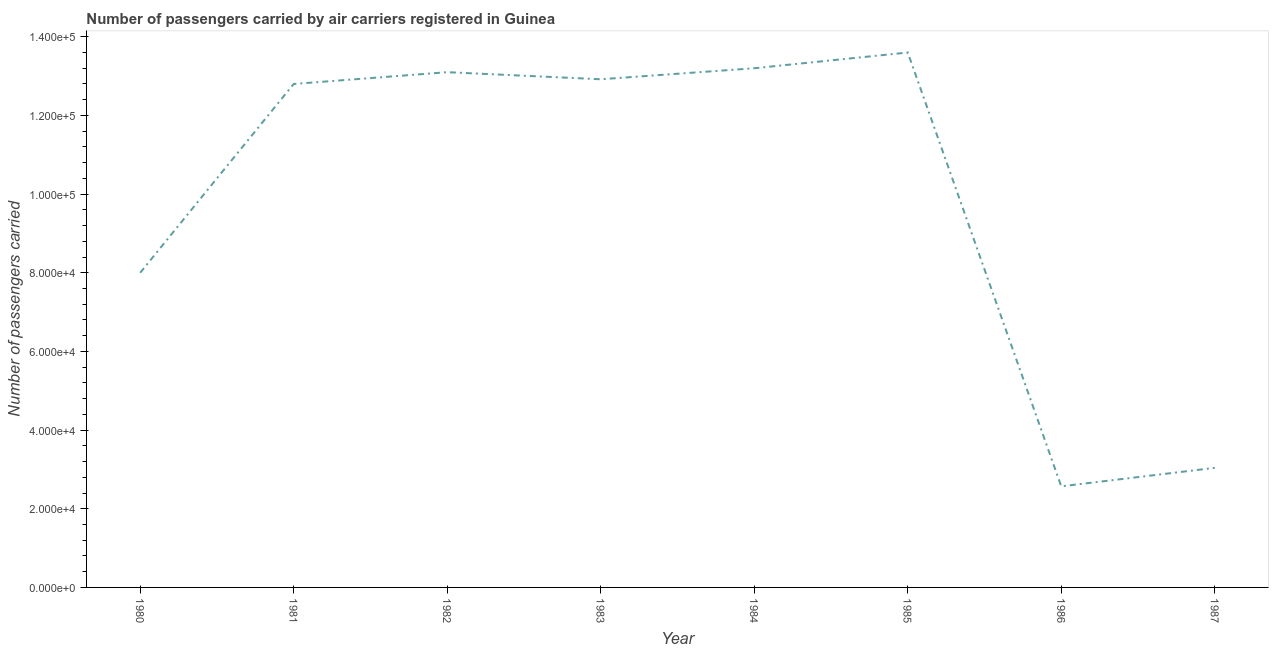What is the number of passengers carried in 1985?
Your answer should be very brief. 1.36e+05. Across all years, what is the maximum number of passengers carried?
Your response must be concise. 1.36e+05. Across all years, what is the minimum number of passengers carried?
Ensure brevity in your answer.  2.57e+04. In which year was the number of passengers carried maximum?
Provide a short and direct response. 1985. What is the sum of the number of passengers carried?
Provide a succinct answer. 7.92e+05. What is the difference between the number of passengers carried in 1981 and 1985?
Provide a succinct answer. -8000. What is the average number of passengers carried per year?
Your answer should be very brief. 9.90e+04. What is the median number of passengers carried?
Keep it short and to the point. 1.29e+05. In how many years, is the number of passengers carried greater than 64000 ?
Offer a very short reply. 6. Do a majority of the years between 1984 and 1985 (inclusive) have number of passengers carried greater than 4000 ?
Provide a short and direct response. Yes. What is the ratio of the number of passengers carried in 1981 to that in 1985?
Ensure brevity in your answer.  0.94. Is the difference between the number of passengers carried in 1983 and 1987 greater than the difference between any two years?
Give a very brief answer. No. What is the difference between the highest and the second highest number of passengers carried?
Provide a short and direct response. 4000. What is the difference between the highest and the lowest number of passengers carried?
Ensure brevity in your answer.  1.10e+05. Does the number of passengers carried monotonically increase over the years?
Provide a short and direct response. No. How many lines are there?
Provide a short and direct response. 1. How many years are there in the graph?
Your response must be concise. 8. Does the graph contain any zero values?
Your response must be concise. No. What is the title of the graph?
Provide a short and direct response. Number of passengers carried by air carriers registered in Guinea. What is the label or title of the X-axis?
Give a very brief answer. Year. What is the label or title of the Y-axis?
Provide a succinct answer. Number of passengers carried. What is the Number of passengers carried of 1980?
Ensure brevity in your answer.  8.00e+04. What is the Number of passengers carried of 1981?
Make the answer very short. 1.28e+05. What is the Number of passengers carried of 1982?
Provide a short and direct response. 1.31e+05. What is the Number of passengers carried in 1983?
Offer a very short reply. 1.29e+05. What is the Number of passengers carried of 1984?
Keep it short and to the point. 1.32e+05. What is the Number of passengers carried in 1985?
Keep it short and to the point. 1.36e+05. What is the Number of passengers carried of 1986?
Offer a very short reply. 2.57e+04. What is the Number of passengers carried in 1987?
Offer a terse response. 3.04e+04. What is the difference between the Number of passengers carried in 1980 and 1981?
Offer a terse response. -4.80e+04. What is the difference between the Number of passengers carried in 1980 and 1982?
Your answer should be very brief. -5.10e+04. What is the difference between the Number of passengers carried in 1980 and 1983?
Ensure brevity in your answer.  -4.92e+04. What is the difference between the Number of passengers carried in 1980 and 1984?
Make the answer very short. -5.20e+04. What is the difference between the Number of passengers carried in 1980 and 1985?
Your answer should be very brief. -5.60e+04. What is the difference between the Number of passengers carried in 1980 and 1986?
Ensure brevity in your answer.  5.43e+04. What is the difference between the Number of passengers carried in 1980 and 1987?
Make the answer very short. 4.96e+04. What is the difference between the Number of passengers carried in 1981 and 1982?
Provide a succinct answer. -3000. What is the difference between the Number of passengers carried in 1981 and 1983?
Offer a terse response. -1200. What is the difference between the Number of passengers carried in 1981 and 1984?
Offer a very short reply. -4000. What is the difference between the Number of passengers carried in 1981 and 1985?
Your answer should be compact. -8000. What is the difference between the Number of passengers carried in 1981 and 1986?
Your answer should be compact. 1.02e+05. What is the difference between the Number of passengers carried in 1981 and 1987?
Provide a short and direct response. 9.76e+04. What is the difference between the Number of passengers carried in 1982 and 1983?
Your response must be concise. 1800. What is the difference between the Number of passengers carried in 1982 and 1984?
Provide a succinct answer. -1000. What is the difference between the Number of passengers carried in 1982 and 1985?
Offer a very short reply. -5000. What is the difference between the Number of passengers carried in 1982 and 1986?
Offer a very short reply. 1.05e+05. What is the difference between the Number of passengers carried in 1982 and 1987?
Provide a succinct answer. 1.01e+05. What is the difference between the Number of passengers carried in 1983 and 1984?
Your response must be concise. -2800. What is the difference between the Number of passengers carried in 1983 and 1985?
Your answer should be very brief. -6800. What is the difference between the Number of passengers carried in 1983 and 1986?
Ensure brevity in your answer.  1.04e+05. What is the difference between the Number of passengers carried in 1983 and 1987?
Keep it short and to the point. 9.88e+04. What is the difference between the Number of passengers carried in 1984 and 1985?
Your answer should be compact. -4000. What is the difference between the Number of passengers carried in 1984 and 1986?
Give a very brief answer. 1.06e+05. What is the difference between the Number of passengers carried in 1984 and 1987?
Provide a succinct answer. 1.02e+05. What is the difference between the Number of passengers carried in 1985 and 1986?
Offer a terse response. 1.10e+05. What is the difference between the Number of passengers carried in 1985 and 1987?
Your answer should be compact. 1.06e+05. What is the difference between the Number of passengers carried in 1986 and 1987?
Your response must be concise. -4700. What is the ratio of the Number of passengers carried in 1980 to that in 1982?
Provide a short and direct response. 0.61. What is the ratio of the Number of passengers carried in 1980 to that in 1983?
Make the answer very short. 0.62. What is the ratio of the Number of passengers carried in 1980 to that in 1984?
Your answer should be very brief. 0.61. What is the ratio of the Number of passengers carried in 1980 to that in 1985?
Provide a succinct answer. 0.59. What is the ratio of the Number of passengers carried in 1980 to that in 1986?
Your answer should be compact. 3.11. What is the ratio of the Number of passengers carried in 1980 to that in 1987?
Make the answer very short. 2.63. What is the ratio of the Number of passengers carried in 1981 to that in 1983?
Offer a very short reply. 0.99. What is the ratio of the Number of passengers carried in 1981 to that in 1984?
Provide a succinct answer. 0.97. What is the ratio of the Number of passengers carried in 1981 to that in 1985?
Give a very brief answer. 0.94. What is the ratio of the Number of passengers carried in 1981 to that in 1986?
Give a very brief answer. 4.98. What is the ratio of the Number of passengers carried in 1981 to that in 1987?
Offer a very short reply. 4.21. What is the ratio of the Number of passengers carried in 1982 to that in 1984?
Your answer should be very brief. 0.99. What is the ratio of the Number of passengers carried in 1982 to that in 1985?
Your response must be concise. 0.96. What is the ratio of the Number of passengers carried in 1982 to that in 1986?
Provide a short and direct response. 5.1. What is the ratio of the Number of passengers carried in 1982 to that in 1987?
Make the answer very short. 4.31. What is the ratio of the Number of passengers carried in 1983 to that in 1986?
Make the answer very short. 5.03. What is the ratio of the Number of passengers carried in 1983 to that in 1987?
Ensure brevity in your answer.  4.25. What is the ratio of the Number of passengers carried in 1984 to that in 1985?
Your response must be concise. 0.97. What is the ratio of the Number of passengers carried in 1984 to that in 1986?
Give a very brief answer. 5.14. What is the ratio of the Number of passengers carried in 1984 to that in 1987?
Your answer should be compact. 4.34. What is the ratio of the Number of passengers carried in 1985 to that in 1986?
Provide a succinct answer. 5.29. What is the ratio of the Number of passengers carried in 1985 to that in 1987?
Keep it short and to the point. 4.47. What is the ratio of the Number of passengers carried in 1986 to that in 1987?
Provide a succinct answer. 0.84. 